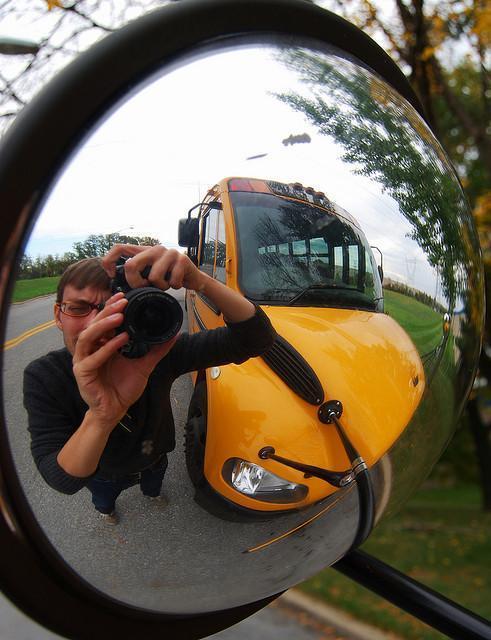How many things are yellow?
Give a very brief answer. 1. How many white trucks are there in the image ?
Give a very brief answer. 0. 